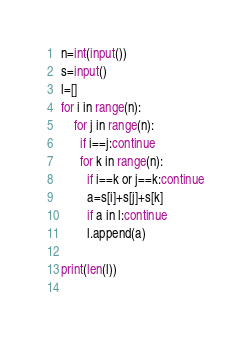Convert code to text. <code><loc_0><loc_0><loc_500><loc_500><_Python_>n=int(input())
s=input()
l=[]
for i in range(n):
    for j in range(n):
      if i==j:continue
      for k in range(n):
        if i==k or j==k:continue
        a=s[i]+s[j]+s[k]
        if a in l:continue
        l.append(a)

print(len(l))     
    </code> 